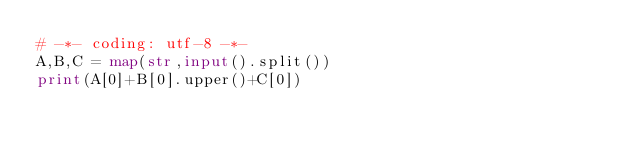Convert code to text. <code><loc_0><loc_0><loc_500><loc_500><_Python_># -*- coding: utf-8 -*-
A,B,C = map(str,input().split())
print(A[0]+B[0].upper()+C[0])</code> 